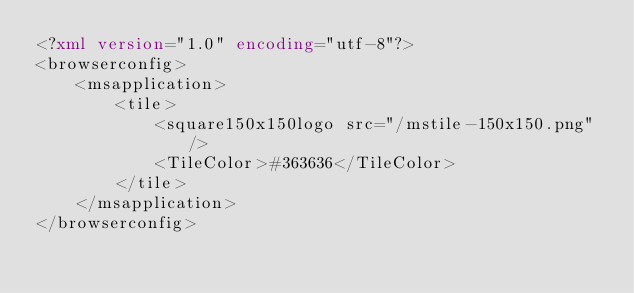Convert code to text. <code><loc_0><loc_0><loc_500><loc_500><_XML_><?xml version="1.0" encoding="utf-8"?>
<browserconfig>
    <msapplication>
        <tile>
            <square150x150logo src="/mstile-150x150.png"/>
            <TileColor>#363636</TileColor>
        </tile>
    </msapplication>
</browserconfig>
</code> 